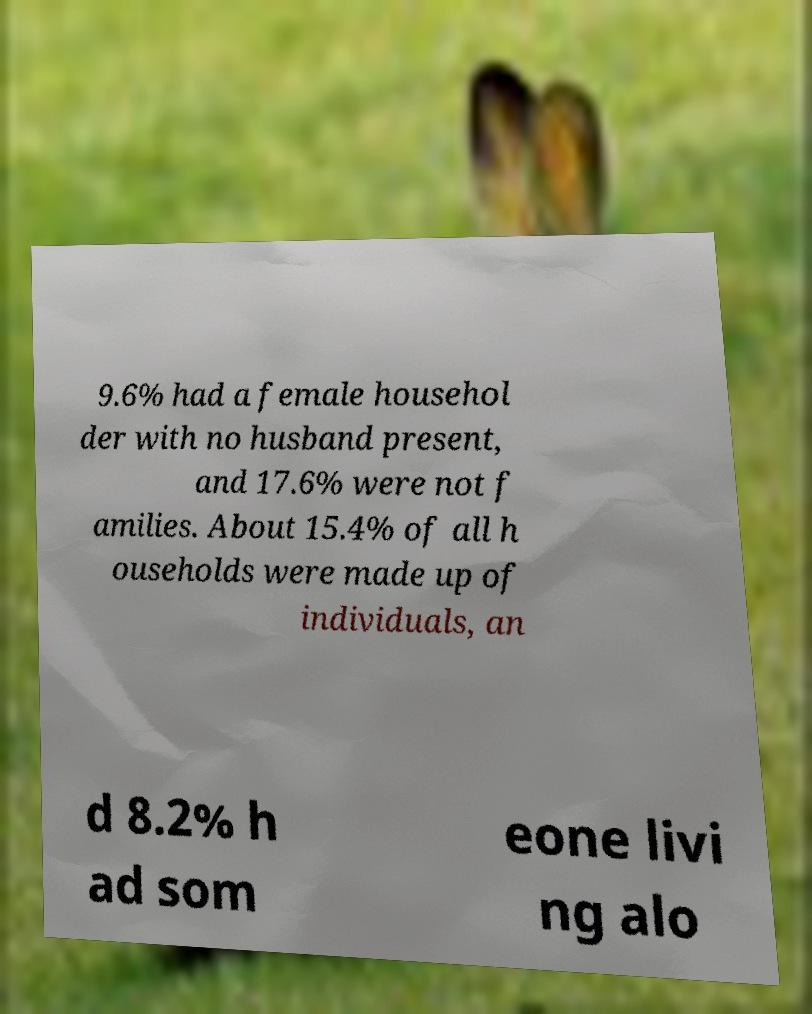Please identify and transcribe the text found in this image. 9.6% had a female househol der with no husband present, and 17.6% were not f amilies. About 15.4% of all h ouseholds were made up of individuals, an d 8.2% h ad som eone livi ng alo 